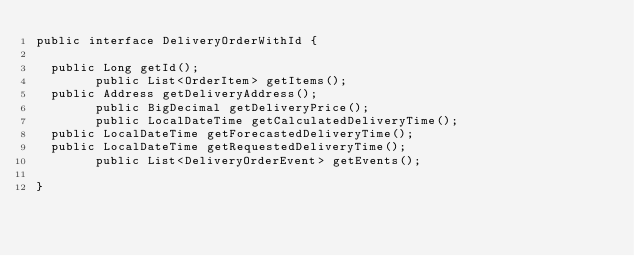Convert code to text. <code><loc_0><loc_0><loc_500><loc_500><_Java_>public interface DeliveryOrderWithId {
    
	public Long getId();
        public List<OrderItem> getItems();
	public Address getDeliveryAddress();
        public BigDecimal getDeliveryPrice();
        public LocalDateTime getCalculatedDeliveryTime();
	public LocalDateTime getForecastedDeliveryTime();
	public LocalDateTime getRequestedDeliveryTime();
        public List<DeliveryOrderEvent> getEvents();
        
}
</code> 